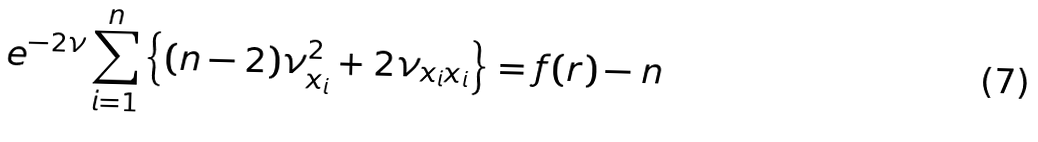Convert formula to latex. <formula><loc_0><loc_0><loc_500><loc_500>e ^ { - 2 \nu } \sum _ { i = 1 } ^ { n } \left \{ ( n - 2 ) \nu _ { x _ { i } } ^ { 2 } + 2 \nu _ { x _ { i } x _ { i } } \right \} = f ( r ) - n</formula> 